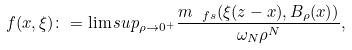Convert formula to latex. <formula><loc_0><loc_0><loc_500><loc_500>f ( x , \xi ) \colon = \lim s u p _ { \rho \to 0 ^ { + } } \frac { { m } _ { \ f s } ( \xi ( z - x ) , B _ { \rho } ( x ) ) } { \omega _ { N } \rho ^ { N } } ,</formula> 